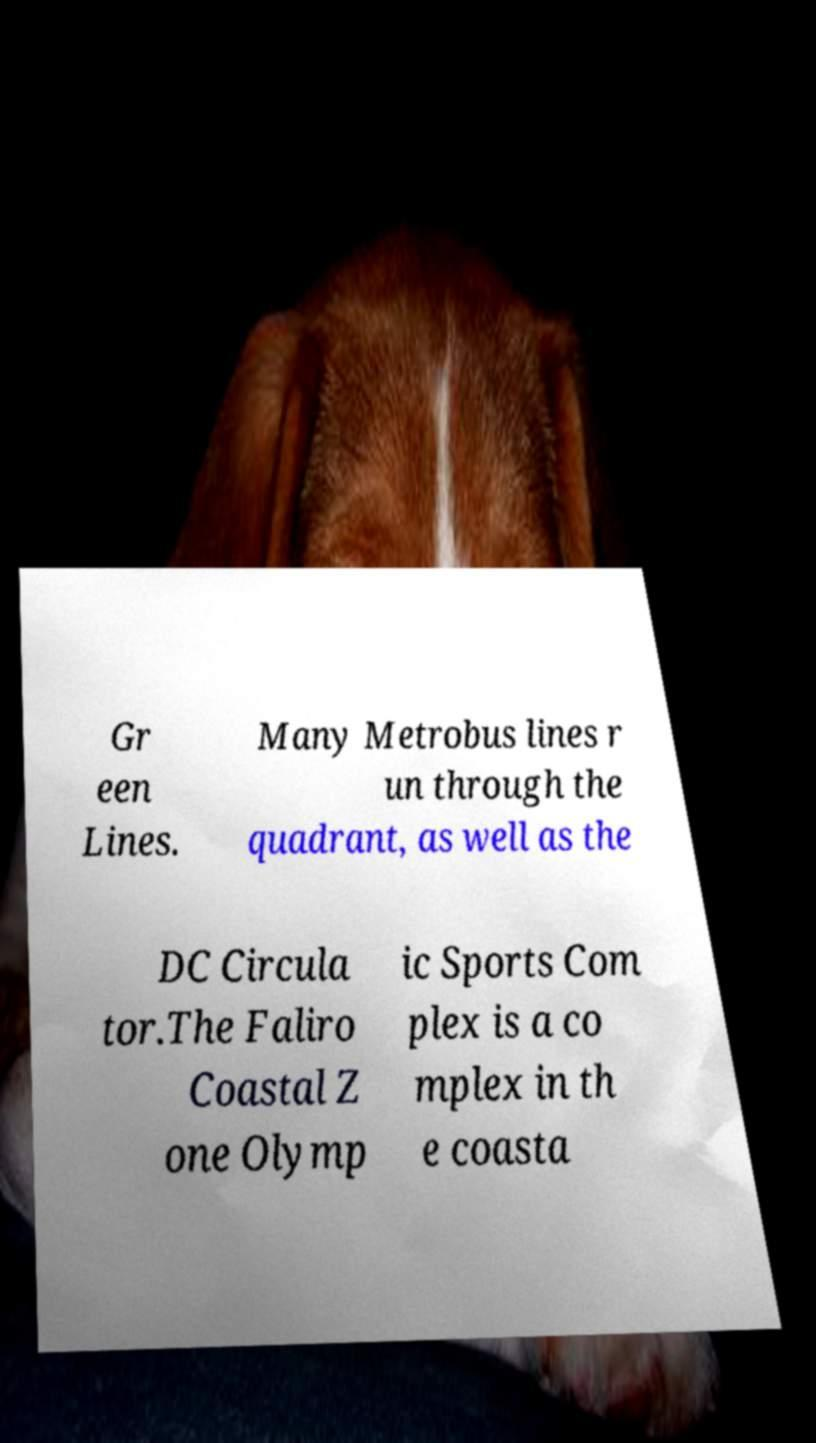What messages or text are displayed in this image? I need them in a readable, typed format. Gr een Lines. Many Metrobus lines r un through the quadrant, as well as the DC Circula tor.The Faliro Coastal Z one Olymp ic Sports Com plex is a co mplex in th e coasta 